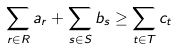Convert formula to latex. <formula><loc_0><loc_0><loc_500><loc_500>\sum _ { r \in R } a _ { r } + \sum _ { s \in S } b _ { s } \geq \sum _ { t \in T } c _ { t }</formula> 